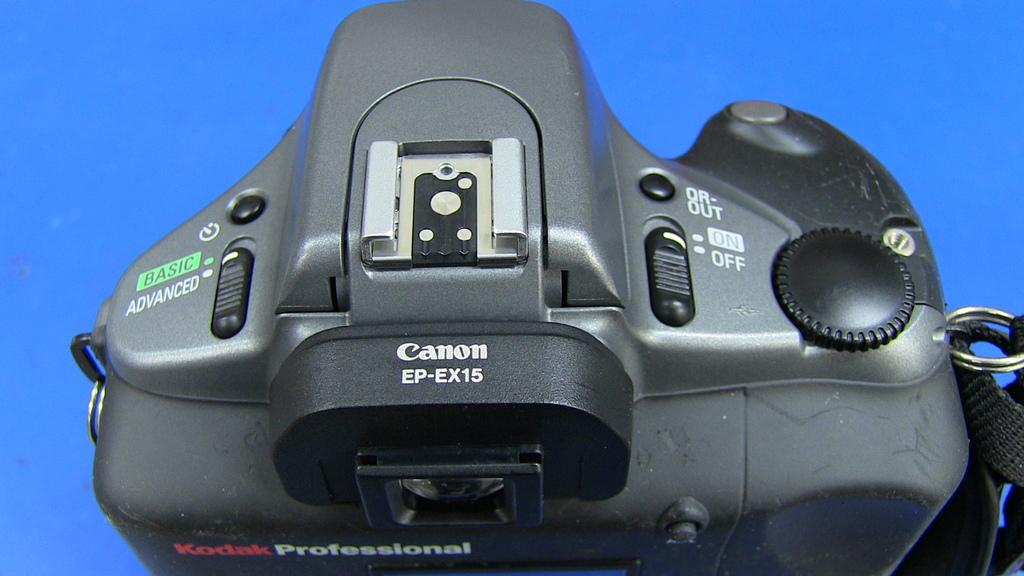Provide a one-sentence caption for the provided image. A Canon camera can be used to take quality professional photographs. 